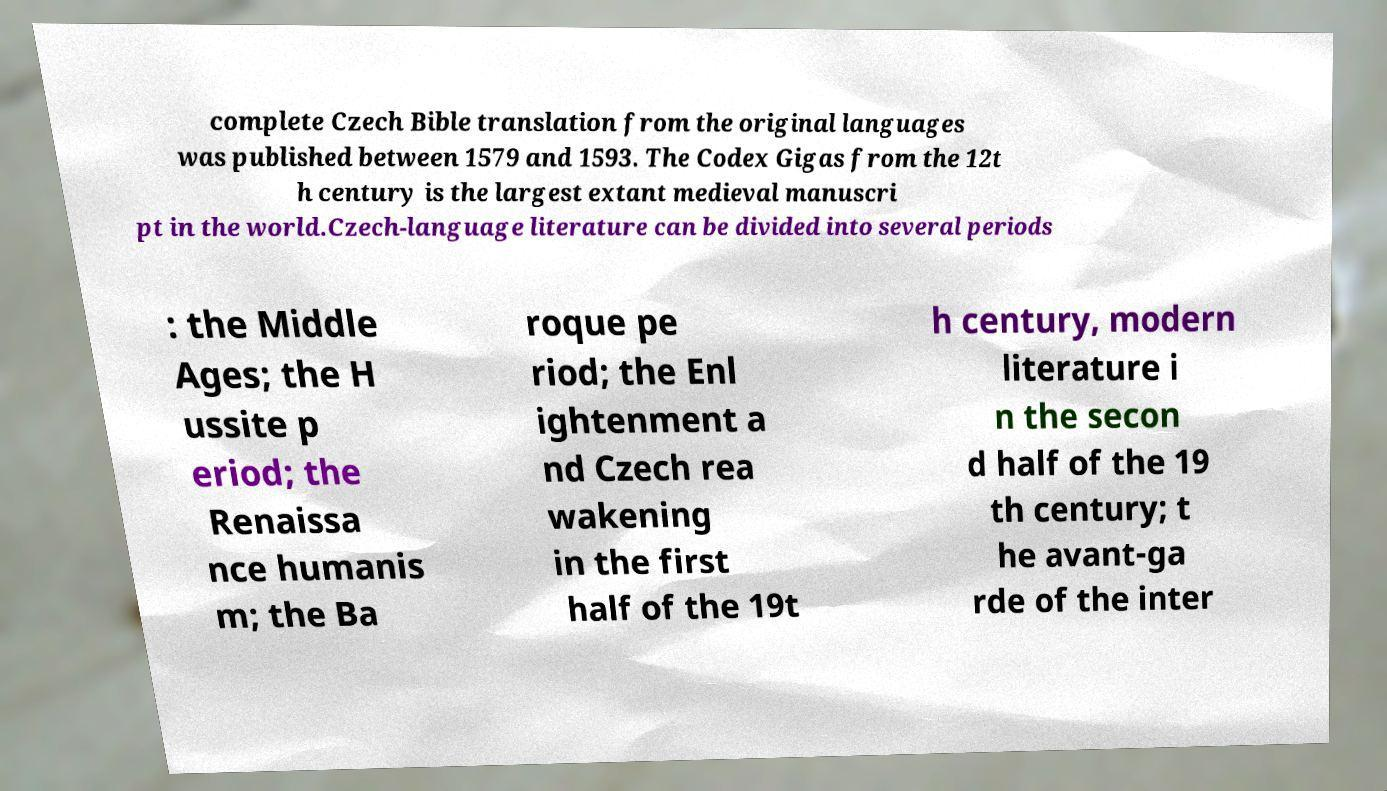Can you read and provide the text displayed in the image?This photo seems to have some interesting text. Can you extract and type it out for me? complete Czech Bible translation from the original languages was published between 1579 and 1593. The Codex Gigas from the 12t h century is the largest extant medieval manuscri pt in the world.Czech-language literature can be divided into several periods : the Middle Ages; the H ussite p eriod; the Renaissa nce humanis m; the Ba roque pe riod; the Enl ightenment a nd Czech rea wakening in the first half of the 19t h century, modern literature i n the secon d half of the 19 th century; t he avant-ga rde of the inter 